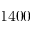<formula> <loc_0><loc_0><loc_500><loc_500>1 4 0 0</formula> 